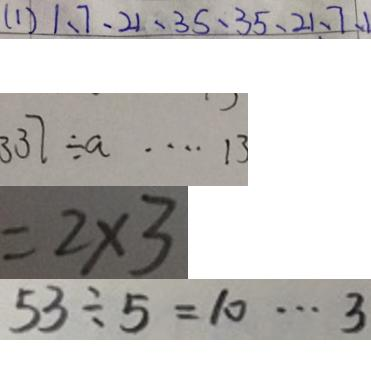Convert formula to latex. <formula><loc_0><loc_0><loc_500><loc_500>( 1 ) 1 、 7 、 2 1 、 3 5 、 3 5 、 2 1 、 7 、 1 
 3 3 7 \div a \cdots 1 3 
 = 2 \times 3 
 5 3 \div 5 = 1 0 \cdots 3</formula> 